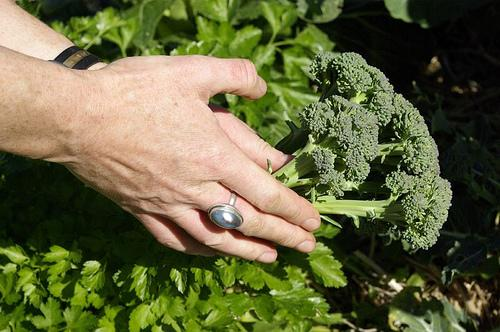Provide a brief caption for the image. Person picking fresh broccoli while wearing a ring, bracelet, and watch in a garden. Evaluate the image quality and describe its details. The image has good quality, showing details like the oval shape silver ring, the silver and black watch, and clipped, clean fingernails. Provide a brief description of the person's physical characteristics and their accessories. The person has white hands, clipped and clean nails, freckles, or age spots on their arm. They are wearing a silver oval-shaped ring, a silver and black watch, and a black and brown bracelet. Count the number of objects and their types in the image. Hands (2), ring (1), watch (1), bracelet (1), broccoli (1), green plants (multiple). List the prominent colors and objects in the image. Silver - ring, Black and brown - bracelet, Green - vegetable, broccoli, plant leaves, stems, Watch - silver and black. Summarize the activities taking place in the image. A person is gardening, picking fresh green broccoli while wearing a silver ring, a bracelet, and a watch, with hands in front of green plants. Identify the main objects and their interactions in the image. Hands interact with broccoli while wearing a ring, bracelet, and watch, surrounded by green leaves and plants. Perform a sentiment analysis of the image. The image has a positive sentiment, suggesting a connection with nature and healthy eating habits. Describe how the person is holding the broccoli. The person's hand is grabbing the broccoli firmly, showcasing their engagement in picking fresh vegetables from the garden. Analyze possible complex reasoning related to the activities in the image. Picking fresh green broccoli suggests that the person values healthy eating, and their accessories suggest attention to style and appearance. 